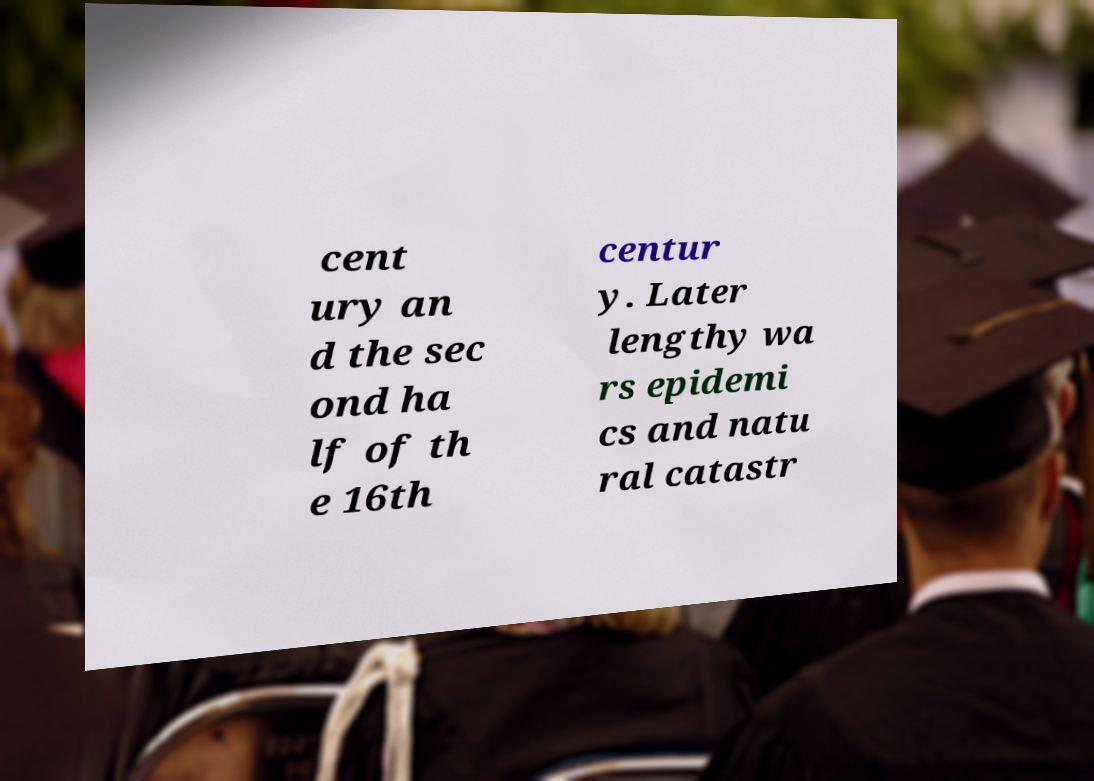Please identify and transcribe the text found in this image. cent ury an d the sec ond ha lf of th e 16th centur y. Later lengthy wa rs epidemi cs and natu ral catastr 